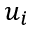<formula> <loc_0><loc_0><loc_500><loc_500>u _ { i }</formula> 